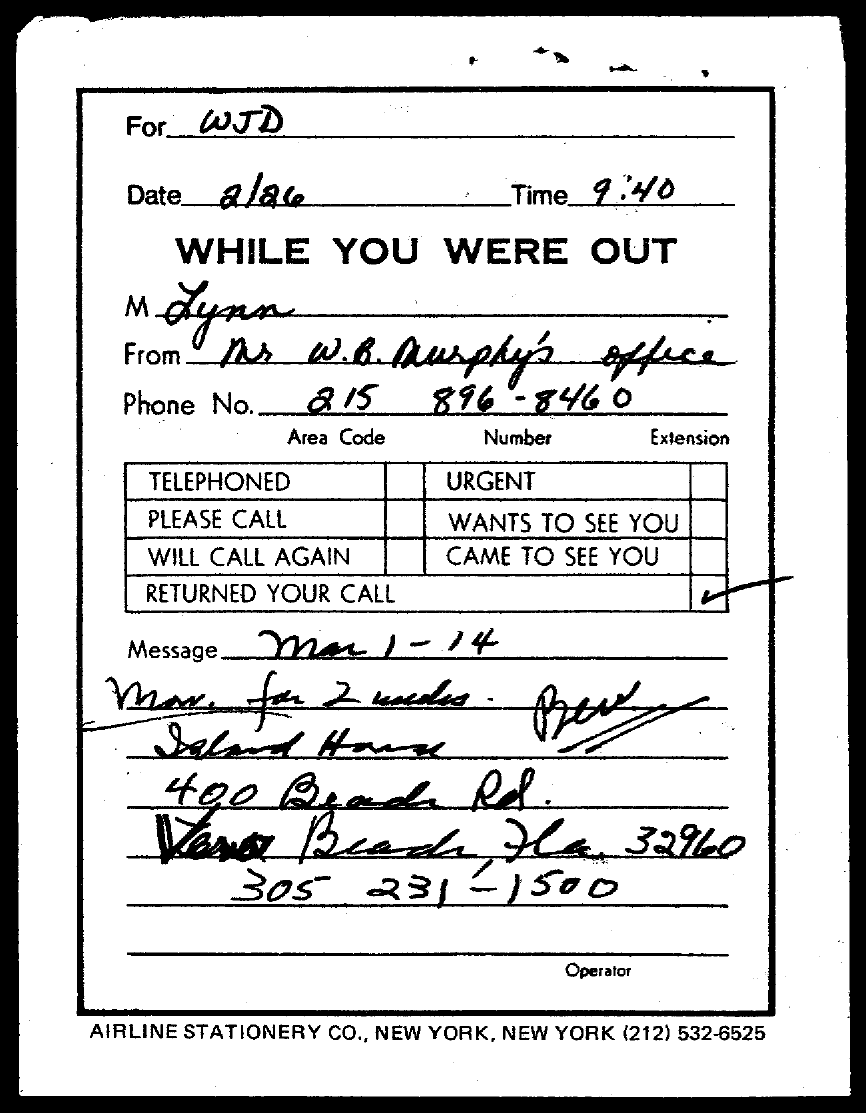To Whom is this note addressed to?
Provide a succinct answer. WJD. What is the Date?
Offer a very short reply. 2/26. What is the time?
Ensure brevity in your answer.  9:40. Who is the message form?
Keep it short and to the point. W.b. murphy's office. What is the Phone No. for Mr. W.B.Murphy's office?
Your response must be concise. 215 896-8460. What is the Phone No. in the message?
Keep it short and to the point. 305 231-1500. 